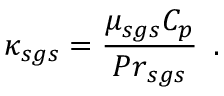<formula> <loc_0><loc_0><loc_500><loc_500>\kappa _ { s g s } = \frac { \mu _ { s g s } C _ { p } } { { P r } _ { s g s } } \, .</formula> 